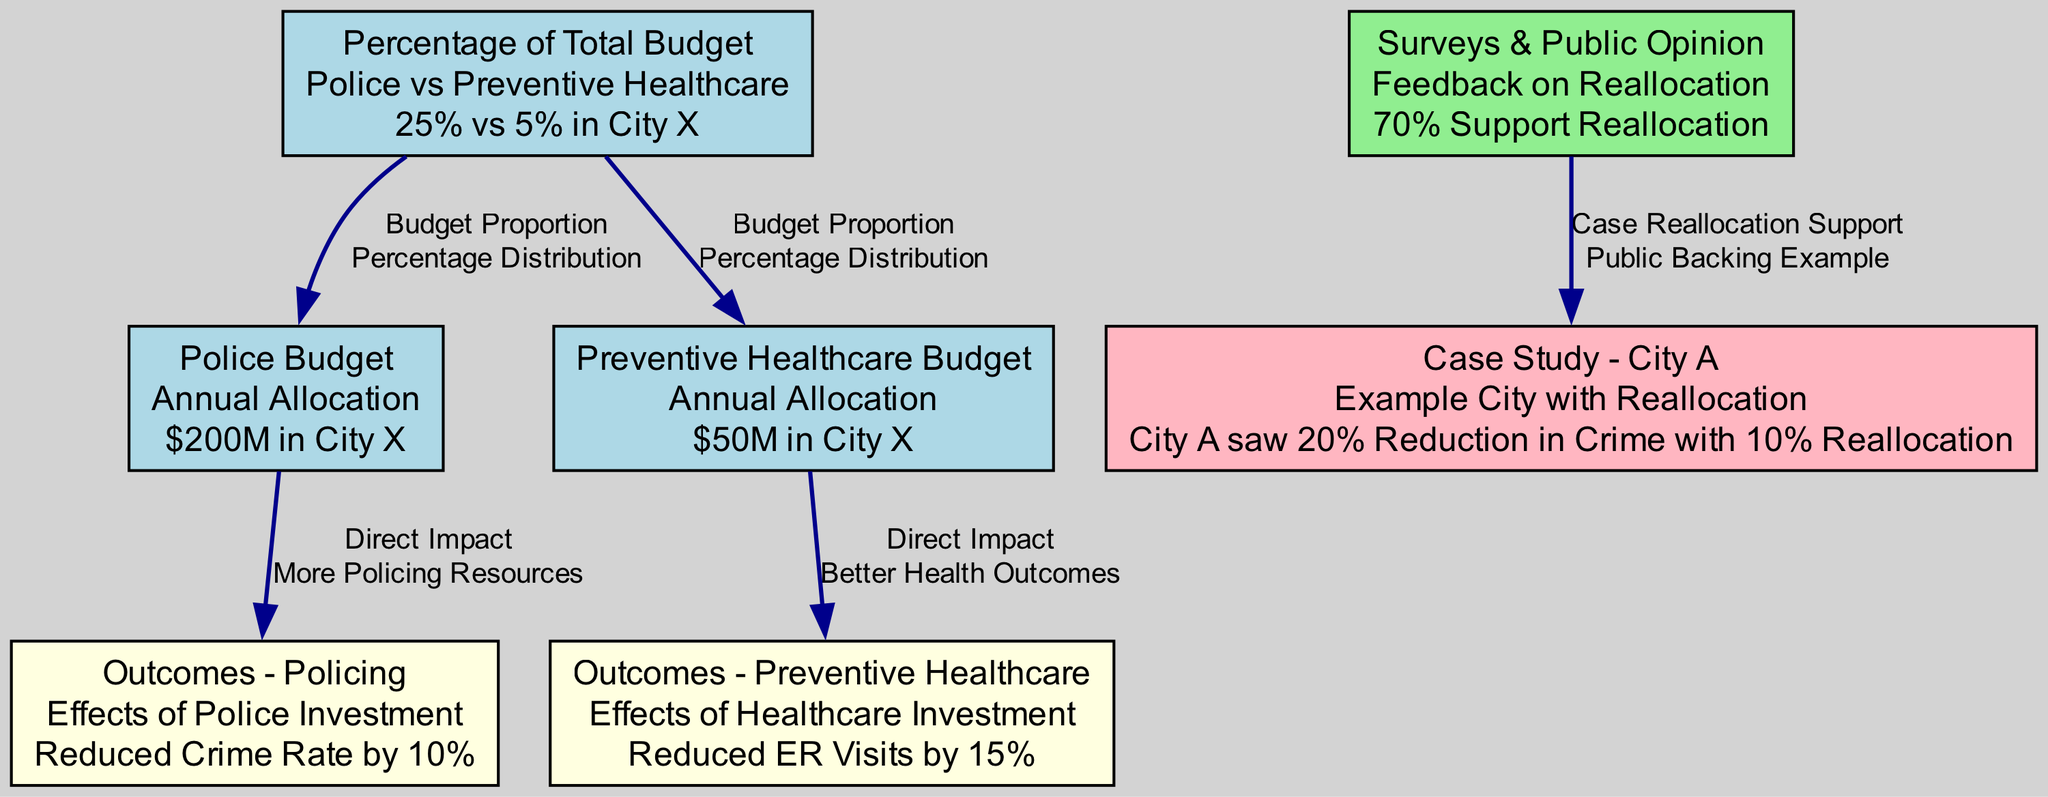What is the annual allocation for the police budget in City X? According to the node labelled "Police Budget," the annual allocation is "$200M in City X."
Answer: $200M in City X What percentage of the total budget is allocated to preventive healthcare in City X? Looking at the "Percentage of Total Budget" node, it indicates "5% in City X" for preventive healthcare.
Answer: 5% in City X What was the outcome of police investment according to the diagram? The "Outcomes - Policing" node states that the effect of police investment resulted in a "Reduced Crime Rate by 10%."
Answer: Reduced Crime Rate by 10% How does the preventive healthcare budget impact healthcare outcomes? The "Outcomes - Preventive Healthcare" node illustrates that the effect of preventive healthcare investment led to a "Reduced ER Visits by 15%."
Answer: Reduced ER Visits by 15% What percentage of the total budget is dedicated to policing in City X? The node "Percentage of Total Budget" shows that the police budget constitutes "25% in City X."
Answer: 25% in City X What public sentiment is reflected in the surveys regarding funding reallocation? The "Surveys & Public Opinion" node indicates that "70% Support Reallocation." This reflects public sentiment supporting the initiative.
Answer: 70% Support Reallocation What case study supports the argument for budget reallocation? The diagram contains a node titled "Case Study - City A," which states that "City A saw 20% Reduction in Crime with 10% Reallocation."
Answer: City A saw 20% Reduction in Crime with 10% Reallocation How are the police budget and preventive healthcare budget connected in the diagram? The diagram shows a dual relationship where both budgets fall under the "Percentage of Total Budget" node indicating their share in the city's budget distribution.
Answer: They are both represented under the "Percentage of Total Budget" node Which investment leads to better health outcomes according to the diagram? The connection indicating that investing in the "Preventive Healthcare Budget" leads to "Better Health Outcomes," specifically noted in the "Outcomes - Preventive Healthcare" node, supports this.
Answer: Preventive Healthcare Budget 